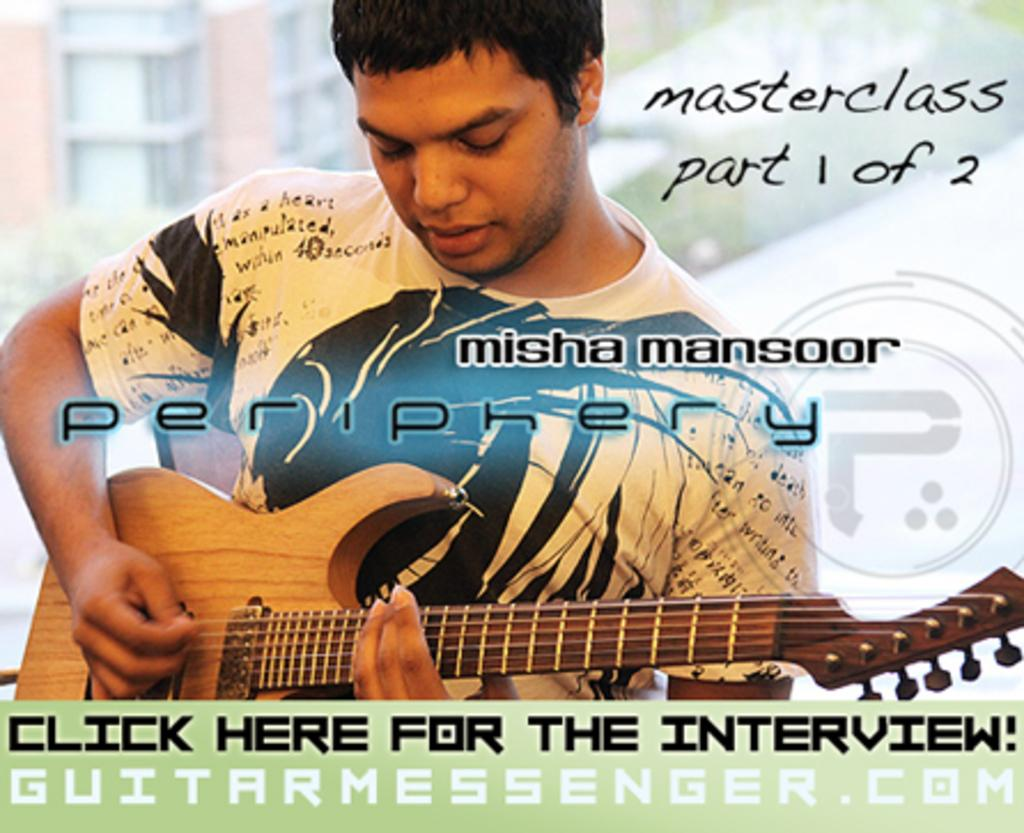What is the man in the image doing? The man is playing a guitar in the image. What is the man wearing while playing the guitar? The man is wearing a white t-shirt. Is there any text present in the image? Yes, there is text present in the image. What type of meat is being cooked in the image? There is no meat or cooking activity present in the image. 